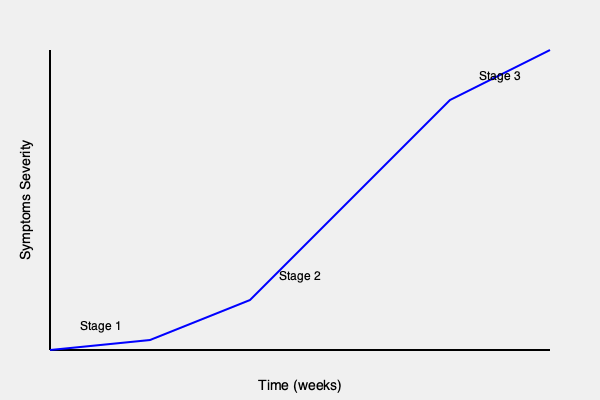Based on the clinical presentation timeline shown in the graph, identify the stages of adrenal insufficiency and describe the key characteristics of each stage. How does this progression inform the diagnostic approach and management strategies for patients with suspected adrenal insufficiency? 1. Stage 1 (Weeks 0-4):
   - Mild symptom severity
   - Patients may experience non-specific symptoms like fatigue, weakness, and mild gastrointestinal disturbances
   - Cortisol levels may be low-normal or slightly decreased
   - Diagnosis is challenging due to subtle presentation

2. Stage 2 (Weeks 4-8):
   - Moderate symptom severity
   - More pronounced symptoms including weight loss, hyperpigmentation, and orthostatic hypotension
   - Cortisol levels are typically below normal range
   - ACTH stimulation test may show suboptimal cortisol response

3. Stage 3 (Weeks 8-12):
   - Severe symptom severity
   - Patients may present with adrenal crisis: severe hypotension, electrolyte imbalances, and altered mental status
   - Cortisol levels are markedly low
   - Immediate treatment with glucocorticoids is crucial

Diagnostic approach:
1. Early stages: High clinical suspicion is needed. Morning cortisol and ACTH levels, followed by ACTH stimulation test
2. Later stages: More obvious clinical presentation, but requires immediate intervention

Management strategies:
1. Stage 1: Close monitoring and possible glucocorticoid replacement if diagnosis is confirmed
2. Stage 2: Initiation of glucocorticoid replacement therapy and patient education
3. Stage 3: Emergency treatment with intravenous hydrocortisone and fluid resuscitation

This progression emphasizes the importance of early diagnosis and treatment to prevent potentially life-threatening adrenal crisis.
Answer: Stage 1: Mild, non-specific symptoms; Stage 2: Moderate symptoms, suboptimal cortisol response; Stage 3: Severe symptoms, adrenal crisis risk. Early diagnosis crucial for preventing life-threatening complications. 